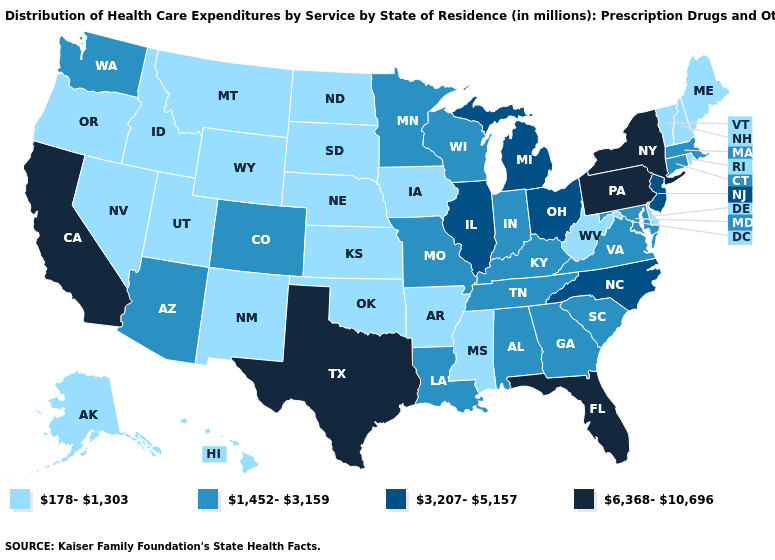What is the highest value in states that border Kansas?
Concise answer only. 1,452-3,159. Which states have the highest value in the USA?
Answer briefly. California, Florida, New York, Pennsylvania, Texas. Which states have the lowest value in the USA?
Give a very brief answer. Alaska, Arkansas, Delaware, Hawaii, Idaho, Iowa, Kansas, Maine, Mississippi, Montana, Nebraska, Nevada, New Hampshire, New Mexico, North Dakota, Oklahoma, Oregon, Rhode Island, South Dakota, Utah, Vermont, West Virginia, Wyoming. Which states have the lowest value in the USA?
Short answer required. Alaska, Arkansas, Delaware, Hawaii, Idaho, Iowa, Kansas, Maine, Mississippi, Montana, Nebraska, Nevada, New Hampshire, New Mexico, North Dakota, Oklahoma, Oregon, Rhode Island, South Dakota, Utah, Vermont, West Virginia, Wyoming. Does Ohio have a lower value than Pennsylvania?
Keep it brief. Yes. Name the states that have a value in the range 1,452-3,159?
Concise answer only. Alabama, Arizona, Colorado, Connecticut, Georgia, Indiana, Kentucky, Louisiana, Maryland, Massachusetts, Minnesota, Missouri, South Carolina, Tennessee, Virginia, Washington, Wisconsin. Is the legend a continuous bar?
Give a very brief answer. No. What is the lowest value in the USA?
Write a very short answer. 178-1,303. Which states hav the highest value in the MidWest?
Be succinct. Illinois, Michigan, Ohio. Does Michigan have a higher value than South Dakota?
Be succinct. Yes. What is the lowest value in the MidWest?
Give a very brief answer. 178-1,303. What is the value of Delaware?
Give a very brief answer. 178-1,303. Which states have the highest value in the USA?
Give a very brief answer. California, Florida, New York, Pennsylvania, Texas. Name the states that have a value in the range 1,452-3,159?
Be succinct. Alabama, Arizona, Colorado, Connecticut, Georgia, Indiana, Kentucky, Louisiana, Maryland, Massachusetts, Minnesota, Missouri, South Carolina, Tennessee, Virginia, Washington, Wisconsin. Among the states that border Georgia , does Florida have the highest value?
Write a very short answer. Yes. 